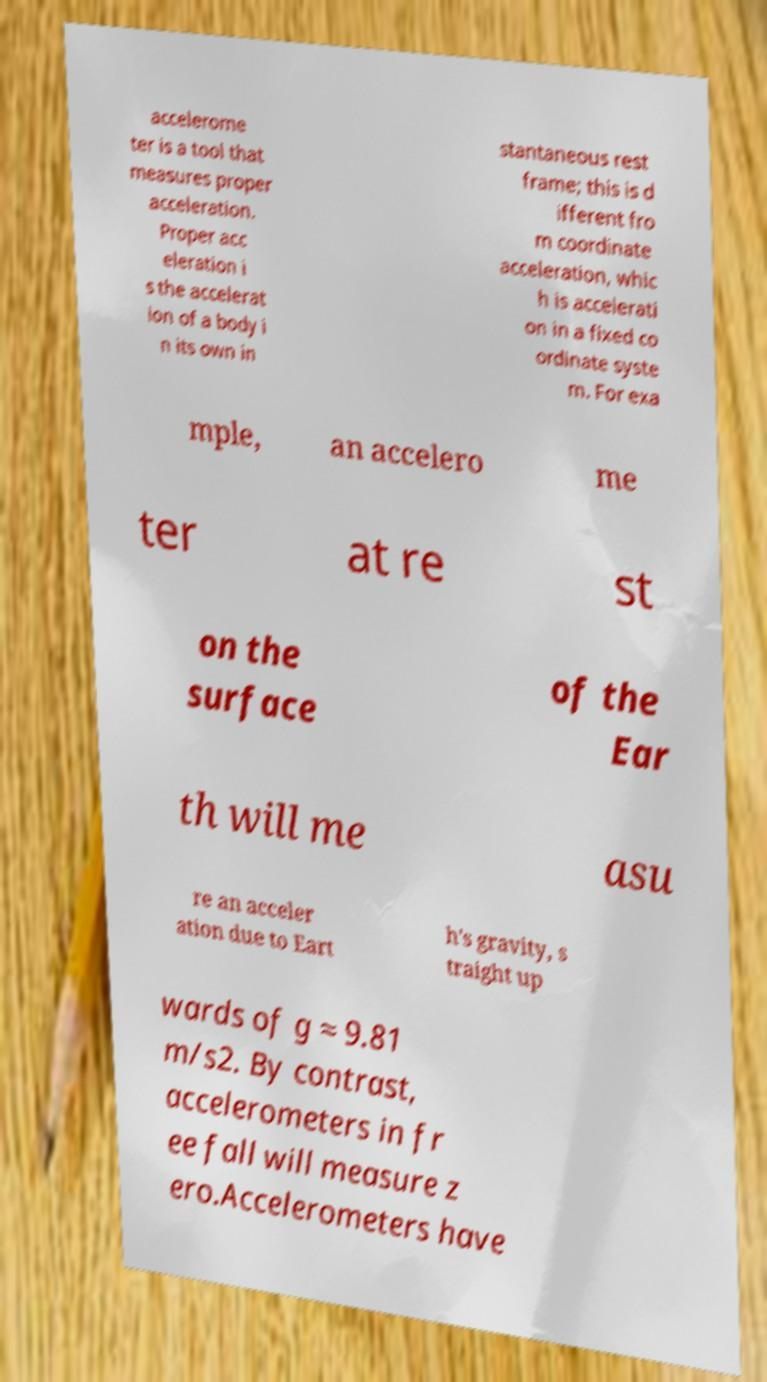I need the written content from this picture converted into text. Can you do that? accelerome ter is a tool that measures proper acceleration. Proper acc eleration i s the accelerat ion of a body i n its own in stantaneous rest frame; this is d ifferent fro m coordinate acceleration, whic h is accelerati on in a fixed co ordinate syste m. For exa mple, an accelero me ter at re st on the surface of the Ear th will me asu re an acceler ation due to Eart h's gravity, s traight up wards of g ≈ 9.81 m/s2. By contrast, accelerometers in fr ee fall will measure z ero.Accelerometers have 